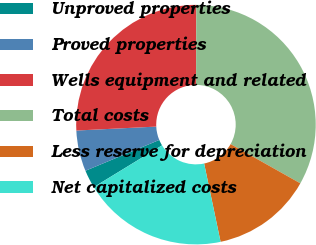Convert chart to OTSL. <chart><loc_0><loc_0><loc_500><loc_500><pie_chart><fcel>Unproved properties<fcel>Proved properties<fcel>Wells equipment and related<fcel>Total costs<fcel>Less reserve for depreciation<fcel>Net capitalized costs<nl><fcel>2.44%<fcel>5.51%<fcel>25.83%<fcel>33.11%<fcel>13.55%<fcel>19.56%<nl></chart> 